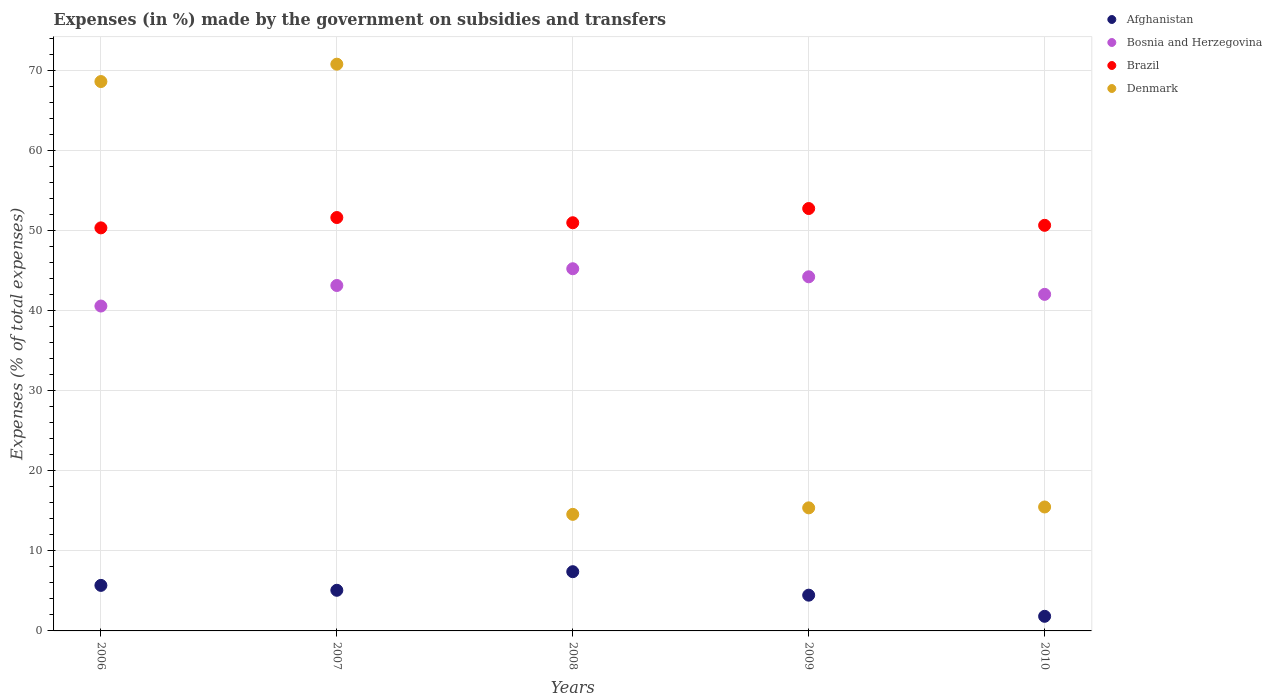How many different coloured dotlines are there?
Your response must be concise. 4. What is the percentage of expenses made by the government on subsidies and transfers in Brazil in 2010?
Ensure brevity in your answer.  50.66. Across all years, what is the maximum percentage of expenses made by the government on subsidies and transfers in Afghanistan?
Make the answer very short. 7.4. Across all years, what is the minimum percentage of expenses made by the government on subsidies and transfers in Denmark?
Your answer should be compact. 14.56. In which year was the percentage of expenses made by the government on subsidies and transfers in Denmark minimum?
Make the answer very short. 2008. What is the total percentage of expenses made by the government on subsidies and transfers in Denmark in the graph?
Your response must be concise. 184.81. What is the difference between the percentage of expenses made by the government on subsidies and transfers in Denmark in 2006 and that in 2008?
Provide a succinct answer. 54.06. What is the difference between the percentage of expenses made by the government on subsidies and transfers in Denmark in 2007 and the percentage of expenses made by the government on subsidies and transfers in Afghanistan in 2009?
Your answer should be very brief. 66.32. What is the average percentage of expenses made by the government on subsidies and transfers in Bosnia and Herzegovina per year?
Give a very brief answer. 43.04. In the year 2006, what is the difference between the percentage of expenses made by the government on subsidies and transfers in Bosnia and Herzegovina and percentage of expenses made by the government on subsidies and transfers in Brazil?
Your answer should be very brief. -9.76. What is the ratio of the percentage of expenses made by the government on subsidies and transfers in Afghanistan in 2009 to that in 2010?
Keep it short and to the point. 2.45. Is the difference between the percentage of expenses made by the government on subsidies and transfers in Bosnia and Herzegovina in 2006 and 2008 greater than the difference between the percentage of expenses made by the government on subsidies and transfers in Brazil in 2006 and 2008?
Offer a very short reply. No. What is the difference between the highest and the second highest percentage of expenses made by the government on subsidies and transfers in Afghanistan?
Provide a short and direct response. 1.71. What is the difference between the highest and the lowest percentage of expenses made by the government on subsidies and transfers in Bosnia and Herzegovina?
Your answer should be compact. 4.66. Is it the case that in every year, the sum of the percentage of expenses made by the government on subsidies and transfers in Afghanistan and percentage of expenses made by the government on subsidies and transfers in Bosnia and Herzegovina  is greater than the sum of percentage of expenses made by the government on subsidies and transfers in Brazil and percentage of expenses made by the government on subsidies and transfers in Denmark?
Your answer should be very brief. No. Does the percentage of expenses made by the government on subsidies and transfers in Denmark monotonically increase over the years?
Your answer should be very brief. No. Is the percentage of expenses made by the government on subsidies and transfers in Afghanistan strictly greater than the percentage of expenses made by the government on subsidies and transfers in Denmark over the years?
Your answer should be compact. No. Is the percentage of expenses made by the government on subsidies and transfers in Brazil strictly less than the percentage of expenses made by the government on subsidies and transfers in Denmark over the years?
Your answer should be compact. No. How many dotlines are there?
Provide a succinct answer. 4. How many years are there in the graph?
Provide a succinct answer. 5. What is the difference between two consecutive major ticks on the Y-axis?
Keep it short and to the point. 10. Are the values on the major ticks of Y-axis written in scientific E-notation?
Give a very brief answer. No. Does the graph contain any zero values?
Offer a terse response. No. Where does the legend appear in the graph?
Offer a terse response. Top right. How are the legend labels stacked?
Provide a short and direct response. Vertical. What is the title of the graph?
Your answer should be compact. Expenses (in %) made by the government on subsidies and transfers. What is the label or title of the Y-axis?
Offer a terse response. Expenses (% of total expenses). What is the Expenses (% of total expenses) in Afghanistan in 2006?
Give a very brief answer. 5.69. What is the Expenses (% of total expenses) of Bosnia and Herzegovina in 2006?
Your response must be concise. 40.58. What is the Expenses (% of total expenses) in Brazil in 2006?
Provide a short and direct response. 50.34. What is the Expenses (% of total expenses) of Denmark in 2006?
Your response must be concise. 68.62. What is the Expenses (% of total expenses) of Afghanistan in 2007?
Provide a short and direct response. 5.08. What is the Expenses (% of total expenses) of Bosnia and Herzegovina in 2007?
Provide a succinct answer. 43.14. What is the Expenses (% of total expenses) of Brazil in 2007?
Your response must be concise. 51.63. What is the Expenses (% of total expenses) in Denmark in 2007?
Ensure brevity in your answer.  70.79. What is the Expenses (% of total expenses) in Afghanistan in 2008?
Provide a short and direct response. 7.4. What is the Expenses (% of total expenses) in Bosnia and Herzegovina in 2008?
Make the answer very short. 45.24. What is the Expenses (% of total expenses) of Brazil in 2008?
Ensure brevity in your answer.  50.98. What is the Expenses (% of total expenses) of Denmark in 2008?
Your response must be concise. 14.56. What is the Expenses (% of total expenses) in Afghanistan in 2009?
Your answer should be very brief. 4.47. What is the Expenses (% of total expenses) in Bosnia and Herzegovina in 2009?
Keep it short and to the point. 44.23. What is the Expenses (% of total expenses) of Brazil in 2009?
Make the answer very short. 52.76. What is the Expenses (% of total expenses) in Denmark in 2009?
Your answer should be compact. 15.37. What is the Expenses (% of total expenses) in Afghanistan in 2010?
Ensure brevity in your answer.  1.82. What is the Expenses (% of total expenses) of Bosnia and Herzegovina in 2010?
Provide a succinct answer. 42.04. What is the Expenses (% of total expenses) in Brazil in 2010?
Your answer should be compact. 50.66. What is the Expenses (% of total expenses) in Denmark in 2010?
Your answer should be very brief. 15.48. Across all years, what is the maximum Expenses (% of total expenses) in Afghanistan?
Offer a terse response. 7.4. Across all years, what is the maximum Expenses (% of total expenses) in Bosnia and Herzegovina?
Your response must be concise. 45.24. Across all years, what is the maximum Expenses (% of total expenses) of Brazil?
Offer a terse response. 52.76. Across all years, what is the maximum Expenses (% of total expenses) in Denmark?
Ensure brevity in your answer.  70.79. Across all years, what is the minimum Expenses (% of total expenses) in Afghanistan?
Provide a succinct answer. 1.82. Across all years, what is the minimum Expenses (% of total expenses) of Bosnia and Herzegovina?
Offer a terse response. 40.58. Across all years, what is the minimum Expenses (% of total expenses) in Brazil?
Make the answer very short. 50.34. Across all years, what is the minimum Expenses (% of total expenses) of Denmark?
Give a very brief answer. 14.56. What is the total Expenses (% of total expenses) in Afghanistan in the graph?
Give a very brief answer. 24.45. What is the total Expenses (% of total expenses) in Bosnia and Herzegovina in the graph?
Your answer should be compact. 215.22. What is the total Expenses (% of total expenses) in Brazil in the graph?
Provide a short and direct response. 256.37. What is the total Expenses (% of total expenses) of Denmark in the graph?
Offer a terse response. 184.81. What is the difference between the Expenses (% of total expenses) of Afghanistan in 2006 and that in 2007?
Make the answer very short. 0.61. What is the difference between the Expenses (% of total expenses) of Bosnia and Herzegovina in 2006 and that in 2007?
Provide a succinct answer. -2.57. What is the difference between the Expenses (% of total expenses) in Brazil in 2006 and that in 2007?
Provide a short and direct response. -1.29. What is the difference between the Expenses (% of total expenses) of Denmark in 2006 and that in 2007?
Give a very brief answer. -2.17. What is the difference between the Expenses (% of total expenses) in Afghanistan in 2006 and that in 2008?
Provide a short and direct response. -1.71. What is the difference between the Expenses (% of total expenses) in Bosnia and Herzegovina in 2006 and that in 2008?
Offer a terse response. -4.66. What is the difference between the Expenses (% of total expenses) of Brazil in 2006 and that in 2008?
Ensure brevity in your answer.  -0.64. What is the difference between the Expenses (% of total expenses) in Denmark in 2006 and that in 2008?
Your response must be concise. 54.06. What is the difference between the Expenses (% of total expenses) of Afghanistan in 2006 and that in 2009?
Make the answer very short. 1.22. What is the difference between the Expenses (% of total expenses) of Bosnia and Herzegovina in 2006 and that in 2009?
Your response must be concise. -3.65. What is the difference between the Expenses (% of total expenses) in Brazil in 2006 and that in 2009?
Provide a short and direct response. -2.41. What is the difference between the Expenses (% of total expenses) of Denmark in 2006 and that in 2009?
Your response must be concise. 53.24. What is the difference between the Expenses (% of total expenses) of Afghanistan in 2006 and that in 2010?
Provide a short and direct response. 3.86. What is the difference between the Expenses (% of total expenses) in Bosnia and Herzegovina in 2006 and that in 2010?
Provide a short and direct response. -1.46. What is the difference between the Expenses (% of total expenses) of Brazil in 2006 and that in 2010?
Your response must be concise. -0.32. What is the difference between the Expenses (% of total expenses) in Denmark in 2006 and that in 2010?
Provide a succinct answer. 53.14. What is the difference between the Expenses (% of total expenses) in Afghanistan in 2007 and that in 2008?
Provide a succinct answer. -2.32. What is the difference between the Expenses (% of total expenses) of Bosnia and Herzegovina in 2007 and that in 2008?
Your answer should be compact. -2.09. What is the difference between the Expenses (% of total expenses) of Brazil in 2007 and that in 2008?
Offer a terse response. 0.65. What is the difference between the Expenses (% of total expenses) in Denmark in 2007 and that in 2008?
Give a very brief answer. 56.23. What is the difference between the Expenses (% of total expenses) of Afghanistan in 2007 and that in 2009?
Your answer should be very brief. 0.61. What is the difference between the Expenses (% of total expenses) of Bosnia and Herzegovina in 2007 and that in 2009?
Give a very brief answer. -1.09. What is the difference between the Expenses (% of total expenses) in Brazil in 2007 and that in 2009?
Your answer should be compact. -1.12. What is the difference between the Expenses (% of total expenses) in Denmark in 2007 and that in 2009?
Give a very brief answer. 55.41. What is the difference between the Expenses (% of total expenses) in Afghanistan in 2007 and that in 2010?
Provide a succinct answer. 3.25. What is the difference between the Expenses (% of total expenses) of Bosnia and Herzegovina in 2007 and that in 2010?
Your response must be concise. 1.11. What is the difference between the Expenses (% of total expenses) in Brazil in 2007 and that in 2010?
Offer a terse response. 0.97. What is the difference between the Expenses (% of total expenses) of Denmark in 2007 and that in 2010?
Make the answer very short. 55.31. What is the difference between the Expenses (% of total expenses) in Afghanistan in 2008 and that in 2009?
Ensure brevity in your answer.  2.93. What is the difference between the Expenses (% of total expenses) of Bosnia and Herzegovina in 2008 and that in 2009?
Your answer should be very brief. 1.01. What is the difference between the Expenses (% of total expenses) of Brazil in 2008 and that in 2009?
Your answer should be very brief. -1.77. What is the difference between the Expenses (% of total expenses) in Denmark in 2008 and that in 2009?
Provide a succinct answer. -0.81. What is the difference between the Expenses (% of total expenses) of Afghanistan in 2008 and that in 2010?
Your answer should be very brief. 5.57. What is the difference between the Expenses (% of total expenses) in Bosnia and Herzegovina in 2008 and that in 2010?
Offer a terse response. 3.2. What is the difference between the Expenses (% of total expenses) in Brazil in 2008 and that in 2010?
Your answer should be very brief. 0.32. What is the difference between the Expenses (% of total expenses) in Denmark in 2008 and that in 2010?
Offer a terse response. -0.92. What is the difference between the Expenses (% of total expenses) of Afghanistan in 2009 and that in 2010?
Give a very brief answer. 2.64. What is the difference between the Expenses (% of total expenses) of Bosnia and Herzegovina in 2009 and that in 2010?
Your answer should be compact. 2.19. What is the difference between the Expenses (% of total expenses) in Brazil in 2009 and that in 2010?
Offer a very short reply. 2.1. What is the difference between the Expenses (% of total expenses) in Denmark in 2009 and that in 2010?
Give a very brief answer. -0.11. What is the difference between the Expenses (% of total expenses) of Afghanistan in 2006 and the Expenses (% of total expenses) of Bosnia and Herzegovina in 2007?
Offer a terse response. -37.46. What is the difference between the Expenses (% of total expenses) of Afghanistan in 2006 and the Expenses (% of total expenses) of Brazil in 2007?
Your answer should be very brief. -45.94. What is the difference between the Expenses (% of total expenses) in Afghanistan in 2006 and the Expenses (% of total expenses) in Denmark in 2007?
Offer a very short reply. -65.1. What is the difference between the Expenses (% of total expenses) in Bosnia and Herzegovina in 2006 and the Expenses (% of total expenses) in Brazil in 2007?
Keep it short and to the point. -11.05. What is the difference between the Expenses (% of total expenses) in Bosnia and Herzegovina in 2006 and the Expenses (% of total expenses) in Denmark in 2007?
Ensure brevity in your answer.  -30.21. What is the difference between the Expenses (% of total expenses) of Brazil in 2006 and the Expenses (% of total expenses) of Denmark in 2007?
Your response must be concise. -20.44. What is the difference between the Expenses (% of total expenses) in Afghanistan in 2006 and the Expenses (% of total expenses) in Bosnia and Herzegovina in 2008?
Your answer should be very brief. -39.55. What is the difference between the Expenses (% of total expenses) of Afghanistan in 2006 and the Expenses (% of total expenses) of Brazil in 2008?
Your response must be concise. -45.29. What is the difference between the Expenses (% of total expenses) in Afghanistan in 2006 and the Expenses (% of total expenses) in Denmark in 2008?
Offer a terse response. -8.87. What is the difference between the Expenses (% of total expenses) in Bosnia and Herzegovina in 2006 and the Expenses (% of total expenses) in Brazil in 2008?
Ensure brevity in your answer.  -10.4. What is the difference between the Expenses (% of total expenses) of Bosnia and Herzegovina in 2006 and the Expenses (% of total expenses) of Denmark in 2008?
Ensure brevity in your answer.  26.02. What is the difference between the Expenses (% of total expenses) in Brazil in 2006 and the Expenses (% of total expenses) in Denmark in 2008?
Offer a terse response. 35.78. What is the difference between the Expenses (% of total expenses) in Afghanistan in 2006 and the Expenses (% of total expenses) in Bosnia and Herzegovina in 2009?
Provide a short and direct response. -38.54. What is the difference between the Expenses (% of total expenses) in Afghanistan in 2006 and the Expenses (% of total expenses) in Brazil in 2009?
Make the answer very short. -47.07. What is the difference between the Expenses (% of total expenses) in Afghanistan in 2006 and the Expenses (% of total expenses) in Denmark in 2009?
Your answer should be compact. -9.68. What is the difference between the Expenses (% of total expenses) in Bosnia and Herzegovina in 2006 and the Expenses (% of total expenses) in Brazil in 2009?
Offer a very short reply. -12.18. What is the difference between the Expenses (% of total expenses) of Bosnia and Herzegovina in 2006 and the Expenses (% of total expenses) of Denmark in 2009?
Your response must be concise. 25.21. What is the difference between the Expenses (% of total expenses) of Brazil in 2006 and the Expenses (% of total expenses) of Denmark in 2009?
Your response must be concise. 34.97. What is the difference between the Expenses (% of total expenses) of Afghanistan in 2006 and the Expenses (% of total expenses) of Bosnia and Herzegovina in 2010?
Ensure brevity in your answer.  -36.35. What is the difference between the Expenses (% of total expenses) of Afghanistan in 2006 and the Expenses (% of total expenses) of Brazil in 2010?
Keep it short and to the point. -44.97. What is the difference between the Expenses (% of total expenses) of Afghanistan in 2006 and the Expenses (% of total expenses) of Denmark in 2010?
Your answer should be very brief. -9.79. What is the difference between the Expenses (% of total expenses) in Bosnia and Herzegovina in 2006 and the Expenses (% of total expenses) in Brazil in 2010?
Offer a very short reply. -10.08. What is the difference between the Expenses (% of total expenses) in Bosnia and Herzegovina in 2006 and the Expenses (% of total expenses) in Denmark in 2010?
Your answer should be very brief. 25.1. What is the difference between the Expenses (% of total expenses) of Brazil in 2006 and the Expenses (% of total expenses) of Denmark in 2010?
Your answer should be compact. 34.86. What is the difference between the Expenses (% of total expenses) in Afghanistan in 2007 and the Expenses (% of total expenses) in Bosnia and Herzegovina in 2008?
Give a very brief answer. -40.16. What is the difference between the Expenses (% of total expenses) of Afghanistan in 2007 and the Expenses (% of total expenses) of Brazil in 2008?
Ensure brevity in your answer.  -45.91. What is the difference between the Expenses (% of total expenses) in Afghanistan in 2007 and the Expenses (% of total expenses) in Denmark in 2008?
Your answer should be very brief. -9.48. What is the difference between the Expenses (% of total expenses) of Bosnia and Herzegovina in 2007 and the Expenses (% of total expenses) of Brazil in 2008?
Provide a short and direct response. -7.84. What is the difference between the Expenses (% of total expenses) in Bosnia and Herzegovina in 2007 and the Expenses (% of total expenses) in Denmark in 2008?
Keep it short and to the point. 28.59. What is the difference between the Expenses (% of total expenses) of Brazil in 2007 and the Expenses (% of total expenses) of Denmark in 2008?
Provide a short and direct response. 37.07. What is the difference between the Expenses (% of total expenses) in Afghanistan in 2007 and the Expenses (% of total expenses) in Bosnia and Herzegovina in 2009?
Your answer should be compact. -39.15. What is the difference between the Expenses (% of total expenses) in Afghanistan in 2007 and the Expenses (% of total expenses) in Brazil in 2009?
Your response must be concise. -47.68. What is the difference between the Expenses (% of total expenses) in Afghanistan in 2007 and the Expenses (% of total expenses) in Denmark in 2009?
Offer a terse response. -10.3. What is the difference between the Expenses (% of total expenses) of Bosnia and Herzegovina in 2007 and the Expenses (% of total expenses) of Brazil in 2009?
Provide a short and direct response. -9.61. What is the difference between the Expenses (% of total expenses) in Bosnia and Herzegovina in 2007 and the Expenses (% of total expenses) in Denmark in 2009?
Your answer should be compact. 27.77. What is the difference between the Expenses (% of total expenses) of Brazil in 2007 and the Expenses (% of total expenses) of Denmark in 2009?
Provide a short and direct response. 36.26. What is the difference between the Expenses (% of total expenses) of Afghanistan in 2007 and the Expenses (% of total expenses) of Bosnia and Herzegovina in 2010?
Offer a very short reply. -36.96. What is the difference between the Expenses (% of total expenses) of Afghanistan in 2007 and the Expenses (% of total expenses) of Brazil in 2010?
Give a very brief answer. -45.58. What is the difference between the Expenses (% of total expenses) in Afghanistan in 2007 and the Expenses (% of total expenses) in Denmark in 2010?
Your answer should be very brief. -10.4. What is the difference between the Expenses (% of total expenses) in Bosnia and Herzegovina in 2007 and the Expenses (% of total expenses) in Brazil in 2010?
Your answer should be compact. -7.52. What is the difference between the Expenses (% of total expenses) in Bosnia and Herzegovina in 2007 and the Expenses (% of total expenses) in Denmark in 2010?
Keep it short and to the point. 27.66. What is the difference between the Expenses (% of total expenses) in Brazil in 2007 and the Expenses (% of total expenses) in Denmark in 2010?
Keep it short and to the point. 36.15. What is the difference between the Expenses (% of total expenses) in Afghanistan in 2008 and the Expenses (% of total expenses) in Bosnia and Herzegovina in 2009?
Offer a terse response. -36.83. What is the difference between the Expenses (% of total expenses) of Afghanistan in 2008 and the Expenses (% of total expenses) of Brazil in 2009?
Ensure brevity in your answer.  -45.36. What is the difference between the Expenses (% of total expenses) of Afghanistan in 2008 and the Expenses (% of total expenses) of Denmark in 2009?
Provide a short and direct response. -7.97. What is the difference between the Expenses (% of total expenses) in Bosnia and Herzegovina in 2008 and the Expenses (% of total expenses) in Brazil in 2009?
Ensure brevity in your answer.  -7.52. What is the difference between the Expenses (% of total expenses) of Bosnia and Herzegovina in 2008 and the Expenses (% of total expenses) of Denmark in 2009?
Your answer should be very brief. 29.87. What is the difference between the Expenses (% of total expenses) of Brazil in 2008 and the Expenses (% of total expenses) of Denmark in 2009?
Your answer should be very brief. 35.61. What is the difference between the Expenses (% of total expenses) in Afghanistan in 2008 and the Expenses (% of total expenses) in Bosnia and Herzegovina in 2010?
Your response must be concise. -34.64. What is the difference between the Expenses (% of total expenses) of Afghanistan in 2008 and the Expenses (% of total expenses) of Brazil in 2010?
Offer a terse response. -43.26. What is the difference between the Expenses (% of total expenses) in Afghanistan in 2008 and the Expenses (% of total expenses) in Denmark in 2010?
Ensure brevity in your answer.  -8.08. What is the difference between the Expenses (% of total expenses) in Bosnia and Herzegovina in 2008 and the Expenses (% of total expenses) in Brazil in 2010?
Your response must be concise. -5.42. What is the difference between the Expenses (% of total expenses) in Bosnia and Herzegovina in 2008 and the Expenses (% of total expenses) in Denmark in 2010?
Provide a succinct answer. 29.76. What is the difference between the Expenses (% of total expenses) of Brazil in 2008 and the Expenses (% of total expenses) of Denmark in 2010?
Your answer should be compact. 35.5. What is the difference between the Expenses (% of total expenses) of Afghanistan in 2009 and the Expenses (% of total expenses) of Bosnia and Herzegovina in 2010?
Offer a very short reply. -37.57. What is the difference between the Expenses (% of total expenses) in Afghanistan in 2009 and the Expenses (% of total expenses) in Brazil in 2010?
Your answer should be compact. -46.19. What is the difference between the Expenses (% of total expenses) in Afghanistan in 2009 and the Expenses (% of total expenses) in Denmark in 2010?
Your answer should be compact. -11.01. What is the difference between the Expenses (% of total expenses) in Bosnia and Herzegovina in 2009 and the Expenses (% of total expenses) in Brazil in 2010?
Offer a terse response. -6.43. What is the difference between the Expenses (% of total expenses) in Bosnia and Herzegovina in 2009 and the Expenses (% of total expenses) in Denmark in 2010?
Make the answer very short. 28.75. What is the difference between the Expenses (% of total expenses) of Brazil in 2009 and the Expenses (% of total expenses) of Denmark in 2010?
Your answer should be very brief. 37.28. What is the average Expenses (% of total expenses) in Afghanistan per year?
Ensure brevity in your answer.  4.89. What is the average Expenses (% of total expenses) in Bosnia and Herzegovina per year?
Provide a short and direct response. 43.04. What is the average Expenses (% of total expenses) of Brazil per year?
Offer a terse response. 51.27. What is the average Expenses (% of total expenses) of Denmark per year?
Provide a succinct answer. 36.96. In the year 2006, what is the difference between the Expenses (% of total expenses) of Afghanistan and Expenses (% of total expenses) of Bosnia and Herzegovina?
Give a very brief answer. -34.89. In the year 2006, what is the difference between the Expenses (% of total expenses) of Afghanistan and Expenses (% of total expenses) of Brazil?
Give a very brief answer. -44.65. In the year 2006, what is the difference between the Expenses (% of total expenses) of Afghanistan and Expenses (% of total expenses) of Denmark?
Offer a very short reply. -62.93. In the year 2006, what is the difference between the Expenses (% of total expenses) of Bosnia and Herzegovina and Expenses (% of total expenses) of Brazil?
Provide a short and direct response. -9.76. In the year 2006, what is the difference between the Expenses (% of total expenses) of Bosnia and Herzegovina and Expenses (% of total expenses) of Denmark?
Provide a succinct answer. -28.04. In the year 2006, what is the difference between the Expenses (% of total expenses) in Brazil and Expenses (% of total expenses) in Denmark?
Keep it short and to the point. -18.27. In the year 2007, what is the difference between the Expenses (% of total expenses) of Afghanistan and Expenses (% of total expenses) of Bosnia and Herzegovina?
Provide a short and direct response. -38.07. In the year 2007, what is the difference between the Expenses (% of total expenses) in Afghanistan and Expenses (% of total expenses) in Brazil?
Provide a succinct answer. -46.56. In the year 2007, what is the difference between the Expenses (% of total expenses) in Afghanistan and Expenses (% of total expenses) in Denmark?
Offer a terse response. -65.71. In the year 2007, what is the difference between the Expenses (% of total expenses) in Bosnia and Herzegovina and Expenses (% of total expenses) in Brazil?
Provide a short and direct response. -8.49. In the year 2007, what is the difference between the Expenses (% of total expenses) of Bosnia and Herzegovina and Expenses (% of total expenses) of Denmark?
Offer a very short reply. -27.64. In the year 2007, what is the difference between the Expenses (% of total expenses) of Brazil and Expenses (% of total expenses) of Denmark?
Your response must be concise. -19.15. In the year 2008, what is the difference between the Expenses (% of total expenses) in Afghanistan and Expenses (% of total expenses) in Bosnia and Herzegovina?
Your answer should be very brief. -37.84. In the year 2008, what is the difference between the Expenses (% of total expenses) of Afghanistan and Expenses (% of total expenses) of Brazil?
Ensure brevity in your answer.  -43.58. In the year 2008, what is the difference between the Expenses (% of total expenses) in Afghanistan and Expenses (% of total expenses) in Denmark?
Keep it short and to the point. -7.16. In the year 2008, what is the difference between the Expenses (% of total expenses) in Bosnia and Herzegovina and Expenses (% of total expenses) in Brazil?
Your answer should be compact. -5.75. In the year 2008, what is the difference between the Expenses (% of total expenses) of Bosnia and Herzegovina and Expenses (% of total expenses) of Denmark?
Provide a succinct answer. 30.68. In the year 2008, what is the difference between the Expenses (% of total expenses) in Brazil and Expenses (% of total expenses) in Denmark?
Keep it short and to the point. 36.42. In the year 2009, what is the difference between the Expenses (% of total expenses) of Afghanistan and Expenses (% of total expenses) of Bosnia and Herzegovina?
Offer a very short reply. -39.76. In the year 2009, what is the difference between the Expenses (% of total expenses) of Afghanistan and Expenses (% of total expenses) of Brazil?
Offer a terse response. -48.29. In the year 2009, what is the difference between the Expenses (% of total expenses) of Afghanistan and Expenses (% of total expenses) of Denmark?
Offer a terse response. -10.91. In the year 2009, what is the difference between the Expenses (% of total expenses) in Bosnia and Herzegovina and Expenses (% of total expenses) in Brazil?
Provide a succinct answer. -8.53. In the year 2009, what is the difference between the Expenses (% of total expenses) of Bosnia and Herzegovina and Expenses (% of total expenses) of Denmark?
Your answer should be very brief. 28.86. In the year 2009, what is the difference between the Expenses (% of total expenses) of Brazil and Expenses (% of total expenses) of Denmark?
Provide a short and direct response. 37.38. In the year 2010, what is the difference between the Expenses (% of total expenses) in Afghanistan and Expenses (% of total expenses) in Bosnia and Herzegovina?
Keep it short and to the point. -40.21. In the year 2010, what is the difference between the Expenses (% of total expenses) in Afghanistan and Expenses (% of total expenses) in Brazil?
Offer a very short reply. -48.83. In the year 2010, what is the difference between the Expenses (% of total expenses) of Afghanistan and Expenses (% of total expenses) of Denmark?
Your answer should be compact. -13.65. In the year 2010, what is the difference between the Expenses (% of total expenses) in Bosnia and Herzegovina and Expenses (% of total expenses) in Brazil?
Your answer should be very brief. -8.62. In the year 2010, what is the difference between the Expenses (% of total expenses) of Bosnia and Herzegovina and Expenses (% of total expenses) of Denmark?
Offer a very short reply. 26.56. In the year 2010, what is the difference between the Expenses (% of total expenses) in Brazil and Expenses (% of total expenses) in Denmark?
Your response must be concise. 35.18. What is the ratio of the Expenses (% of total expenses) of Afghanistan in 2006 to that in 2007?
Your answer should be compact. 1.12. What is the ratio of the Expenses (% of total expenses) in Bosnia and Herzegovina in 2006 to that in 2007?
Provide a short and direct response. 0.94. What is the ratio of the Expenses (% of total expenses) in Brazil in 2006 to that in 2007?
Keep it short and to the point. 0.97. What is the ratio of the Expenses (% of total expenses) in Denmark in 2006 to that in 2007?
Keep it short and to the point. 0.97. What is the ratio of the Expenses (% of total expenses) in Afghanistan in 2006 to that in 2008?
Keep it short and to the point. 0.77. What is the ratio of the Expenses (% of total expenses) in Bosnia and Herzegovina in 2006 to that in 2008?
Ensure brevity in your answer.  0.9. What is the ratio of the Expenses (% of total expenses) of Brazil in 2006 to that in 2008?
Ensure brevity in your answer.  0.99. What is the ratio of the Expenses (% of total expenses) in Denmark in 2006 to that in 2008?
Give a very brief answer. 4.71. What is the ratio of the Expenses (% of total expenses) of Afghanistan in 2006 to that in 2009?
Ensure brevity in your answer.  1.27. What is the ratio of the Expenses (% of total expenses) of Bosnia and Herzegovina in 2006 to that in 2009?
Your answer should be very brief. 0.92. What is the ratio of the Expenses (% of total expenses) in Brazil in 2006 to that in 2009?
Provide a short and direct response. 0.95. What is the ratio of the Expenses (% of total expenses) in Denmark in 2006 to that in 2009?
Offer a terse response. 4.46. What is the ratio of the Expenses (% of total expenses) of Afghanistan in 2006 to that in 2010?
Give a very brief answer. 3.12. What is the ratio of the Expenses (% of total expenses) in Bosnia and Herzegovina in 2006 to that in 2010?
Provide a short and direct response. 0.97. What is the ratio of the Expenses (% of total expenses) of Brazil in 2006 to that in 2010?
Provide a succinct answer. 0.99. What is the ratio of the Expenses (% of total expenses) in Denmark in 2006 to that in 2010?
Offer a terse response. 4.43. What is the ratio of the Expenses (% of total expenses) in Afghanistan in 2007 to that in 2008?
Give a very brief answer. 0.69. What is the ratio of the Expenses (% of total expenses) in Bosnia and Herzegovina in 2007 to that in 2008?
Make the answer very short. 0.95. What is the ratio of the Expenses (% of total expenses) of Brazil in 2007 to that in 2008?
Make the answer very short. 1.01. What is the ratio of the Expenses (% of total expenses) of Denmark in 2007 to that in 2008?
Your answer should be compact. 4.86. What is the ratio of the Expenses (% of total expenses) of Afghanistan in 2007 to that in 2009?
Keep it short and to the point. 1.14. What is the ratio of the Expenses (% of total expenses) of Bosnia and Herzegovina in 2007 to that in 2009?
Provide a short and direct response. 0.98. What is the ratio of the Expenses (% of total expenses) of Brazil in 2007 to that in 2009?
Your response must be concise. 0.98. What is the ratio of the Expenses (% of total expenses) of Denmark in 2007 to that in 2009?
Provide a short and direct response. 4.61. What is the ratio of the Expenses (% of total expenses) of Afghanistan in 2007 to that in 2010?
Provide a succinct answer. 2.78. What is the ratio of the Expenses (% of total expenses) in Bosnia and Herzegovina in 2007 to that in 2010?
Your answer should be very brief. 1.03. What is the ratio of the Expenses (% of total expenses) in Brazil in 2007 to that in 2010?
Offer a very short reply. 1.02. What is the ratio of the Expenses (% of total expenses) of Denmark in 2007 to that in 2010?
Your response must be concise. 4.57. What is the ratio of the Expenses (% of total expenses) of Afghanistan in 2008 to that in 2009?
Ensure brevity in your answer.  1.66. What is the ratio of the Expenses (% of total expenses) in Bosnia and Herzegovina in 2008 to that in 2009?
Provide a short and direct response. 1.02. What is the ratio of the Expenses (% of total expenses) of Brazil in 2008 to that in 2009?
Provide a succinct answer. 0.97. What is the ratio of the Expenses (% of total expenses) of Denmark in 2008 to that in 2009?
Your answer should be compact. 0.95. What is the ratio of the Expenses (% of total expenses) in Afghanistan in 2008 to that in 2010?
Keep it short and to the point. 4.05. What is the ratio of the Expenses (% of total expenses) of Bosnia and Herzegovina in 2008 to that in 2010?
Offer a terse response. 1.08. What is the ratio of the Expenses (% of total expenses) of Brazil in 2008 to that in 2010?
Your answer should be very brief. 1.01. What is the ratio of the Expenses (% of total expenses) of Denmark in 2008 to that in 2010?
Offer a terse response. 0.94. What is the ratio of the Expenses (% of total expenses) in Afghanistan in 2009 to that in 2010?
Make the answer very short. 2.45. What is the ratio of the Expenses (% of total expenses) of Bosnia and Herzegovina in 2009 to that in 2010?
Your answer should be very brief. 1.05. What is the ratio of the Expenses (% of total expenses) in Brazil in 2009 to that in 2010?
Provide a succinct answer. 1.04. What is the ratio of the Expenses (% of total expenses) in Denmark in 2009 to that in 2010?
Your response must be concise. 0.99. What is the difference between the highest and the second highest Expenses (% of total expenses) of Afghanistan?
Your answer should be compact. 1.71. What is the difference between the highest and the second highest Expenses (% of total expenses) of Bosnia and Herzegovina?
Keep it short and to the point. 1.01. What is the difference between the highest and the second highest Expenses (% of total expenses) of Brazil?
Provide a short and direct response. 1.12. What is the difference between the highest and the second highest Expenses (% of total expenses) in Denmark?
Your answer should be compact. 2.17. What is the difference between the highest and the lowest Expenses (% of total expenses) of Afghanistan?
Make the answer very short. 5.57. What is the difference between the highest and the lowest Expenses (% of total expenses) in Bosnia and Herzegovina?
Your answer should be compact. 4.66. What is the difference between the highest and the lowest Expenses (% of total expenses) in Brazil?
Provide a short and direct response. 2.41. What is the difference between the highest and the lowest Expenses (% of total expenses) in Denmark?
Your answer should be very brief. 56.23. 